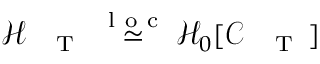<formula> <loc_0><loc_0><loc_500><loc_500>\mathcal { H } _ { { T } } \stackrel { l o c } { \simeq } \mathcal { H } _ { 0 } [ \mathcal { C } _ { { T } } ]</formula> 